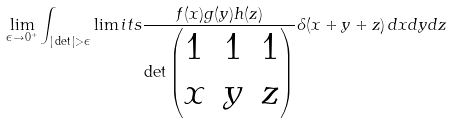<formula> <loc_0><loc_0><loc_500><loc_500>\lim _ { \epsilon \to 0 ^ { + } } \int _ { | \det | > \epsilon } \lim i t s \frac { f ( x ) g ( y ) h ( z ) } { \det \begin{pmatrix} 1 & 1 & 1 \\ x & y & z \end{pmatrix} } \delta ( x + y + z ) \, d x d y d z</formula> 